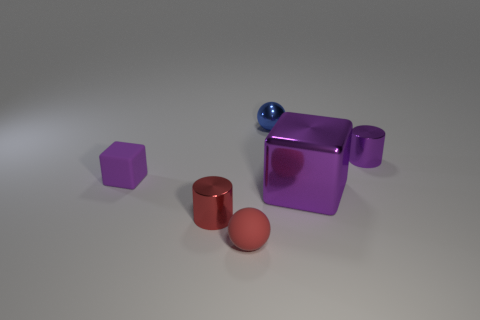Add 1 yellow objects. How many objects exist? 7 Subtract all tiny green spheres. Subtract all balls. How many objects are left? 4 Add 6 tiny rubber balls. How many tiny rubber balls are left? 7 Add 6 spheres. How many spheres exist? 8 Subtract 0 blue cylinders. How many objects are left? 6 Subtract all cylinders. How many objects are left? 4 